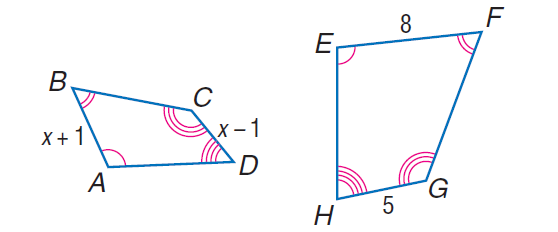Answer the mathemtical geometry problem and directly provide the correct option letter.
Question: Each pair of polygons is similar. Find C D.
Choices: A: 3.333 B: \frac { 10 } { 3 } C: 4 D: 10 B 